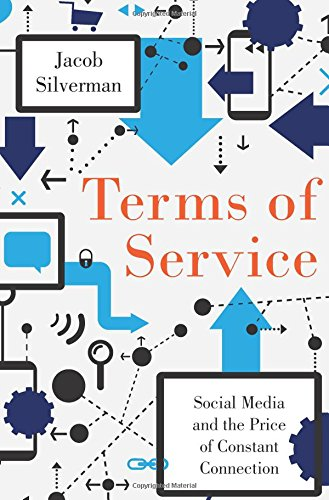What are some key issues discussed in this book? The book discusses several critical issues including privacy concerns, the altering of social interactions by social media, and the broader societal changes driven by constant digital connectivity. 